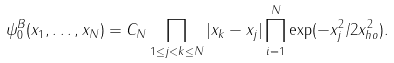Convert formula to latex. <formula><loc_0><loc_0><loc_500><loc_500>\psi _ { 0 } ^ { B } ( x _ { 1 } , \dots , x _ { N } ) = C _ { N } \prod _ { 1 \leq j < k \leq N } | x _ { k } - x _ { j } | \prod _ { i = 1 } ^ { N } \exp ( - x _ { j } ^ { 2 } / 2 x ^ { 2 } _ { h o } ) .</formula> 